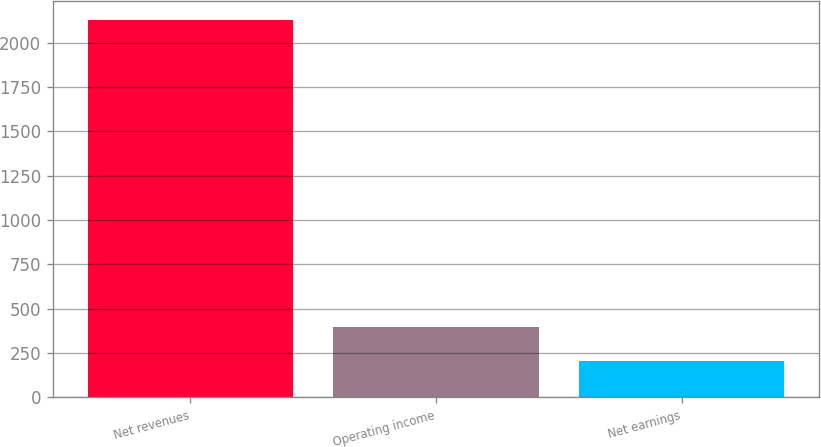<chart> <loc_0><loc_0><loc_500><loc_500><bar_chart><fcel>Net revenues<fcel>Operating income<fcel>Net earnings<nl><fcel>2128<fcel>397.39<fcel>205.1<nl></chart> 